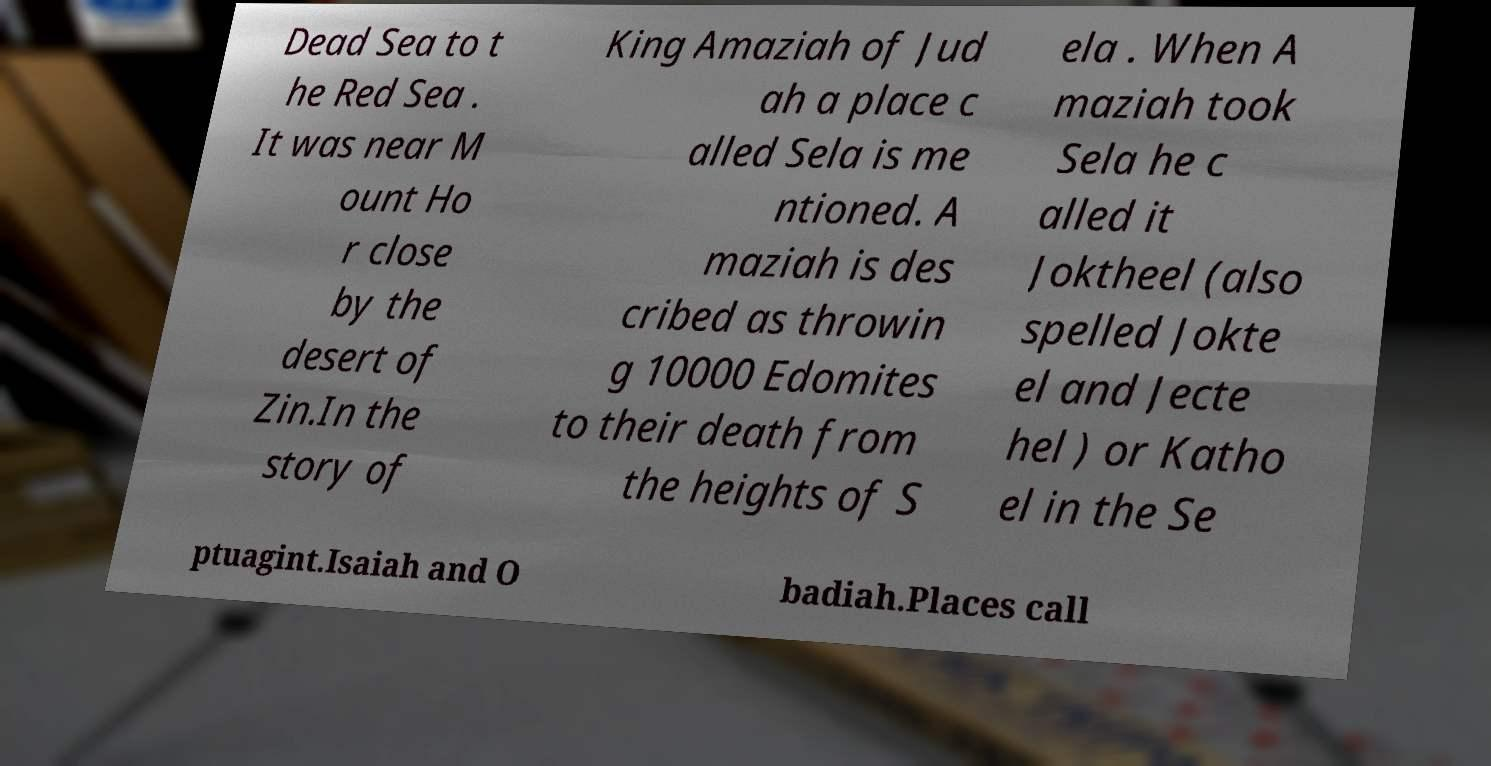I need the written content from this picture converted into text. Can you do that? Dead Sea to t he Red Sea . It was near M ount Ho r close by the desert of Zin.In the story of King Amaziah of Jud ah a place c alled Sela is me ntioned. A maziah is des cribed as throwin g 10000 Edomites to their death from the heights of S ela . When A maziah took Sela he c alled it Joktheel (also spelled Jokte el and Jecte hel ) or Katho el in the Se ptuagint.Isaiah and O badiah.Places call 